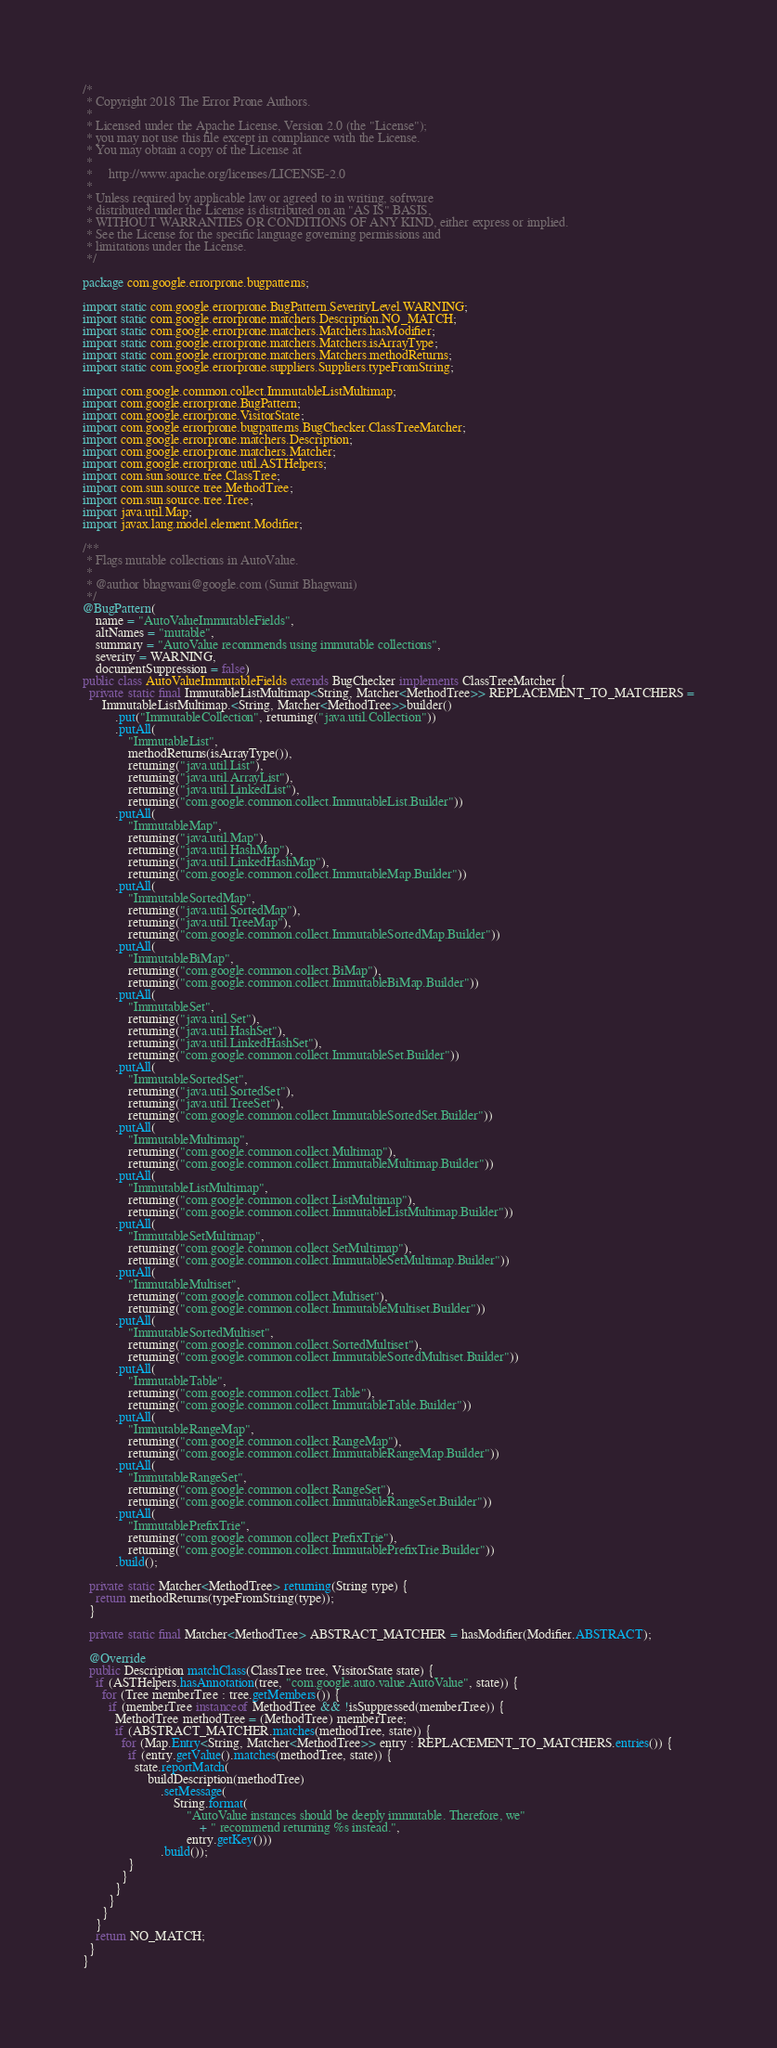<code> <loc_0><loc_0><loc_500><loc_500><_Java_>/*
 * Copyright 2018 The Error Prone Authors.
 *
 * Licensed under the Apache License, Version 2.0 (the "License");
 * you may not use this file except in compliance with the License.
 * You may obtain a copy of the License at
 *
 *     http://www.apache.org/licenses/LICENSE-2.0
 *
 * Unless required by applicable law or agreed to in writing, software
 * distributed under the License is distributed on an "AS IS" BASIS,
 * WITHOUT WARRANTIES OR CONDITIONS OF ANY KIND, either express or implied.
 * See the License for the specific language governing permissions and
 * limitations under the License.
 */

package com.google.errorprone.bugpatterns;

import static com.google.errorprone.BugPattern.SeverityLevel.WARNING;
import static com.google.errorprone.matchers.Description.NO_MATCH;
import static com.google.errorprone.matchers.Matchers.hasModifier;
import static com.google.errorprone.matchers.Matchers.isArrayType;
import static com.google.errorprone.matchers.Matchers.methodReturns;
import static com.google.errorprone.suppliers.Suppliers.typeFromString;

import com.google.common.collect.ImmutableListMultimap;
import com.google.errorprone.BugPattern;
import com.google.errorprone.VisitorState;
import com.google.errorprone.bugpatterns.BugChecker.ClassTreeMatcher;
import com.google.errorprone.matchers.Description;
import com.google.errorprone.matchers.Matcher;
import com.google.errorprone.util.ASTHelpers;
import com.sun.source.tree.ClassTree;
import com.sun.source.tree.MethodTree;
import com.sun.source.tree.Tree;
import java.util.Map;
import javax.lang.model.element.Modifier;

/**
 * Flags mutable collections in AutoValue.
 *
 * @author bhagwani@google.com (Sumit Bhagwani)
 */
@BugPattern(
    name = "AutoValueImmutableFields",
    altNames = "mutable",
    summary = "AutoValue recommends using immutable collections",
    severity = WARNING,
    documentSuppression = false)
public class AutoValueImmutableFields extends BugChecker implements ClassTreeMatcher {
  private static final ImmutableListMultimap<String, Matcher<MethodTree>> REPLACEMENT_TO_MATCHERS =
      ImmutableListMultimap.<String, Matcher<MethodTree>>builder()
          .put("ImmutableCollection", returning("java.util.Collection"))
          .putAll(
              "ImmutableList",
              methodReturns(isArrayType()),
              returning("java.util.List"),
              returning("java.util.ArrayList"),
              returning("java.util.LinkedList"),
              returning("com.google.common.collect.ImmutableList.Builder"))
          .putAll(
              "ImmutableMap",
              returning("java.util.Map"),
              returning("java.util.HashMap"),
              returning("java.util.LinkedHashMap"),
              returning("com.google.common.collect.ImmutableMap.Builder"))
          .putAll(
              "ImmutableSortedMap",
              returning("java.util.SortedMap"),
              returning("java.util.TreeMap"),
              returning("com.google.common.collect.ImmutableSortedMap.Builder"))
          .putAll(
              "ImmutableBiMap",
              returning("com.google.common.collect.BiMap"),
              returning("com.google.common.collect.ImmutableBiMap.Builder"))
          .putAll(
              "ImmutableSet",
              returning("java.util.Set"),
              returning("java.util.HashSet"),
              returning("java.util.LinkedHashSet"),
              returning("com.google.common.collect.ImmutableSet.Builder"))
          .putAll(
              "ImmutableSortedSet",
              returning("java.util.SortedSet"),
              returning("java.util.TreeSet"),
              returning("com.google.common.collect.ImmutableSortedSet.Builder"))
          .putAll(
              "ImmutableMultimap",
              returning("com.google.common.collect.Multimap"),
              returning("com.google.common.collect.ImmutableMultimap.Builder"))
          .putAll(
              "ImmutableListMultimap",
              returning("com.google.common.collect.ListMultimap"),
              returning("com.google.common.collect.ImmutableListMultimap.Builder"))
          .putAll(
              "ImmutableSetMultimap",
              returning("com.google.common.collect.SetMultimap"),
              returning("com.google.common.collect.ImmutableSetMultimap.Builder"))
          .putAll(
              "ImmutableMultiset",
              returning("com.google.common.collect.Multiset"),
              returning("com.google.common.collect.ImmutableMultiset.Builder"))
          .putAll(
              "ImmutableSortedMultiset",
              returning("com.google.common.collect.SortedMultiset"),
              returning("com.google.common.collect.ImmutableSortedMultiset.Builder"))
          .putAll(
              "ImmutableTable",
              returning("com.google.common.collect.Table"),
              returning("com.google.common.collect.ImmutableTable.Builder"))
          .putAll(
              "ImmutableRangeMap",
              returning("com.google.common.collect.RangeMap"),
              returning("com.google.common.collect.ImmutableRangeMap.Builder"))
          .putAll(
              "ImmutableRangeSet",
              returning("com.google.common.collect.RangeSet"),
              returning("com.google.common.collect.ImmutableRangeSet.Builder"))
          .putAll(
              "ImmutablePrefixTrie",
              returning("com.google.common.collect.PrefixTrie"),
              returning("com.google.common.collect.ImmutablePrefixTrie.Builder"))
          .build();

  private static Matcher<MethodTree> returning(String type) {
    return methodReturns(typeFromString(type));
  }

  private static final Matcher<MethodTree> ABSTRACT_MATCHER = hasModifier(Modifier.ABSTRACT);

  @Override
  public Description matchClass(ClassTree tree, VisitorState state) {
    if (ASTHelpers.hasAnnotation(tree, "com.google.auto.value.AutoValue", state)) {
      for (Tree memberTree : tree.getMembers()) {
        if (memberTree instanceof MethodTree && !isSuppressed(memberTree)) {
          MethodTree methodTree = (MethodTree) memberTree;
          if (ABSTRACT_MATCHER.matches(methodTree, state)) {
            for (Map.Entry<String, Matcher<MethodTree>> entry : REPLACEMENT_TO_MATCHERS.entries()) {
              if (entry.getValue().matches(methodTree, state)) {
                state.reportMatch(
                    buildDescription(methodTree)
                        .setMessage(
                            String.format(
                                "AutoValue instances should be deeply immutable. Therefore, we"
                                    + " recommend returning %s instead.",
                                entry.getKey()))
                        .build());
              }
            }
          }
        }
      }
    }
    return NO_MATCH;
  }
}
</code> 